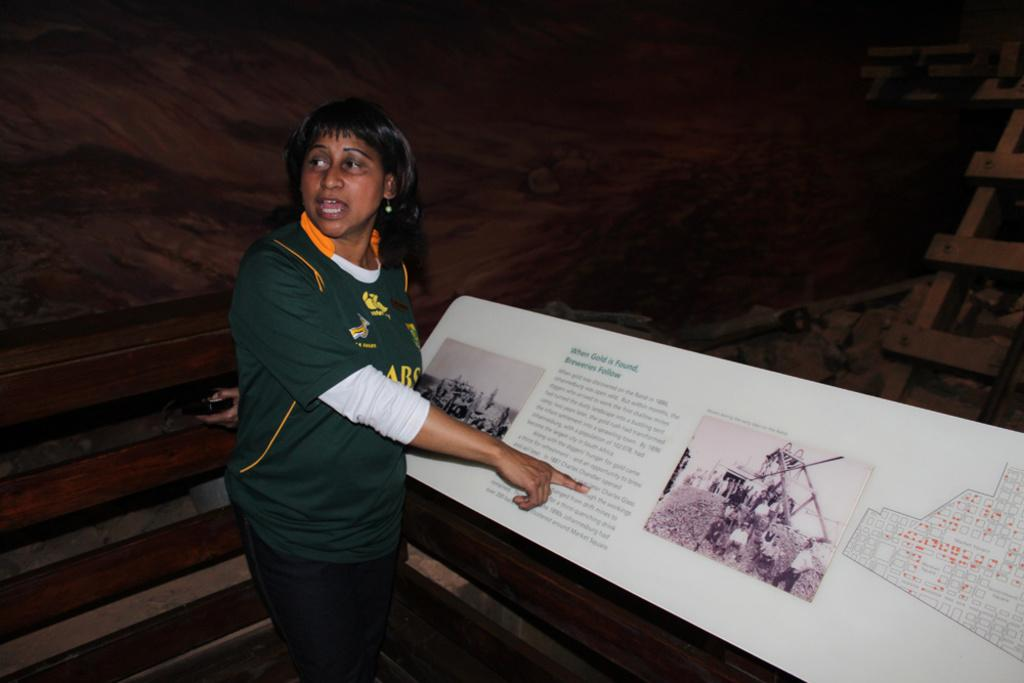Who or what is present in the image? There is a person in the image. What is the person interacting with in the image? There is a board in the image, which the person may be interacting with. What other objects can be seen in the image? There are other objects in the image, but their specific details are not mentioned in the provided facts. What can be seen in the background of the image? There is a wall and wooden objects in the background of the image, as well as other objects. What type of wool is being spun by the person in the image? There is no wool or spinning activity present in the image. What brass objects can be seen in the image? There is no brass present in the image. 